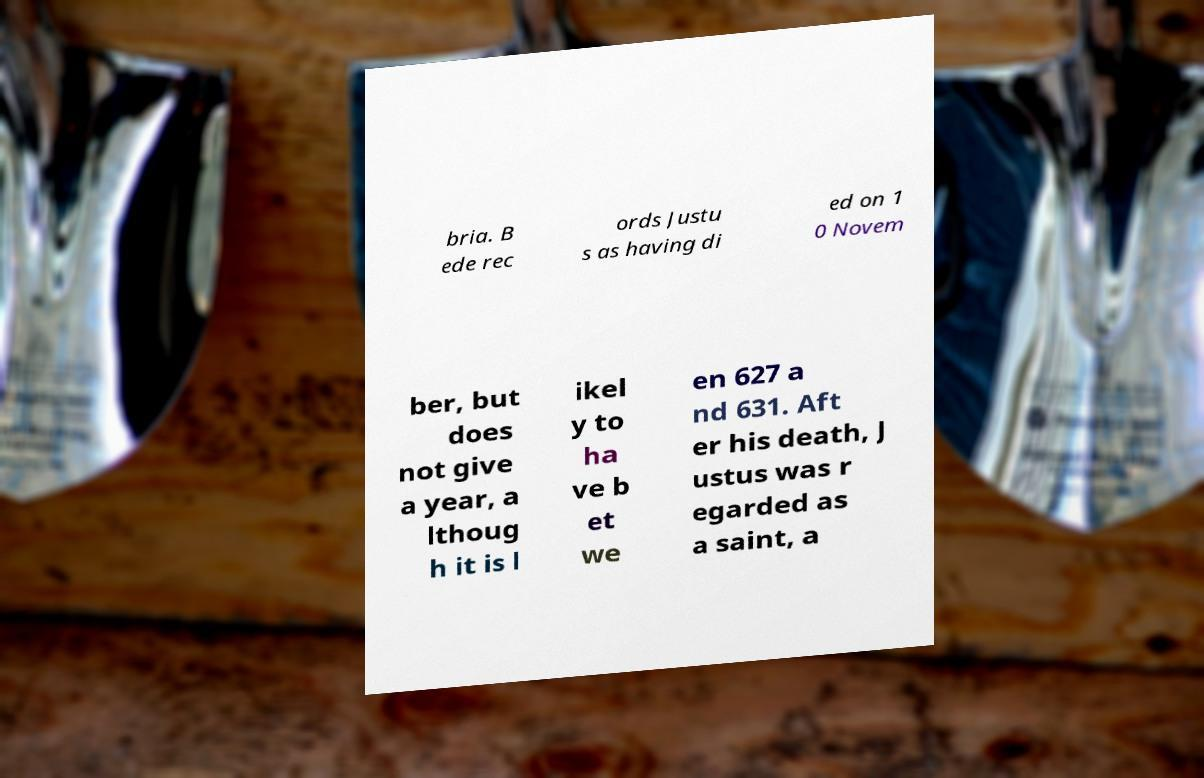Could you assist in decoding the text presented in this image and type it out clearly? bria. B ede rec ords Justu s as having di ed on 1 0 Novem ber, but does not give a year, a lthoug h it is l ikel y to ha ve b et we en 627 a nd 631. Aft er his death, J ustus was r egarded as a saint, a 